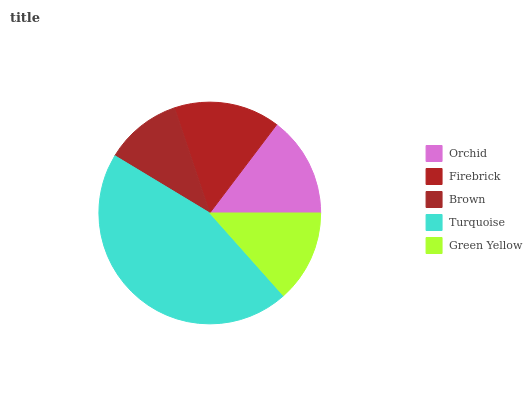Is Brown the minimum?
Answer yes or no. Yes. Is Turquoise the maximum?
Answer yes or no. Yes. Is Firebrick the minimum?
Answer yes or no. No. Is Firebrick the maximum?
Answer yes or no. No. Is Firebrick greater than Orchid?
Answer yes or no. Yes. Is Orchid less than Firebrick?
Answer yes or no. Yes. Is Orchid greater than Firebrick?
Answer yes or no. No. Is Firebrick less than Orchid?
Answer yes or no. No. Is Orchid the high median?
Answer yes or no. Yes. Is Orchid the low median?
Answer yes or no. Yes. Is Firebrick the high median?
Answer yes or no. No. Is Brown the low median?
Answer yes or no. No. 